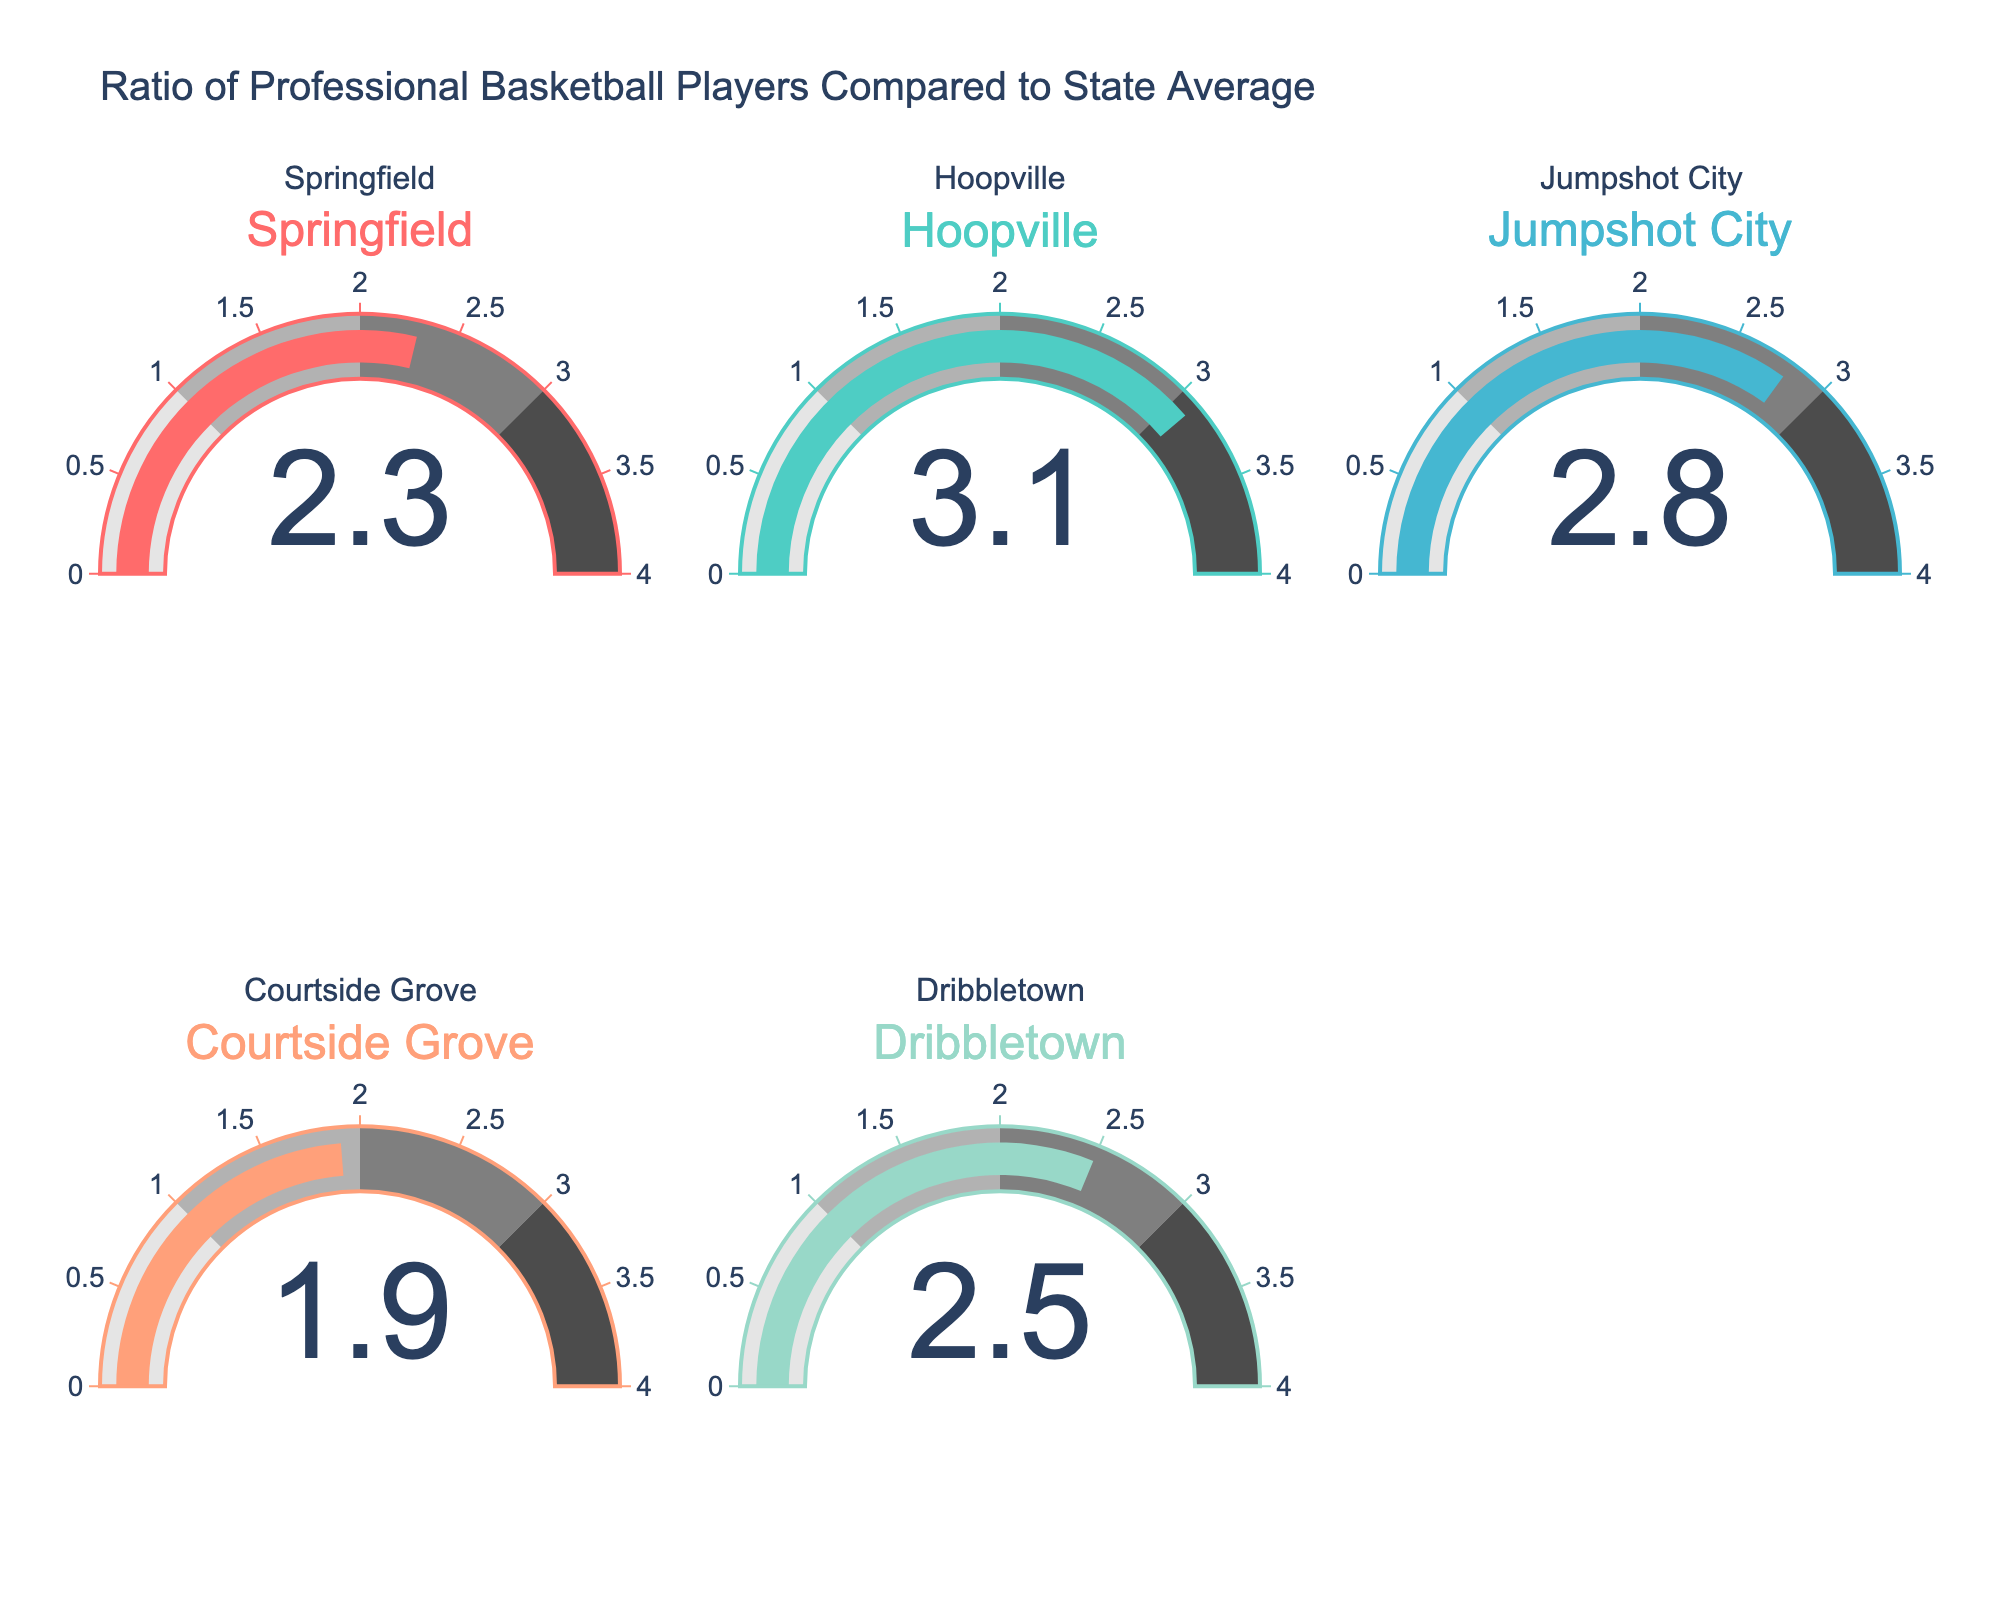Which town has the highest ratio of professional basketball players compared to the state average? By examining the gauges, the highest ratio gauge is in the second plot labeled "Hoopville" with a value of 3.1
Answer: Hoopville Which town has the lowest ratio of professional basketball players compared to the state average? The lowest ratio is found in the gauge labeled "Courtside Grove" with a value of 1.9
Answer: Courtside Grove What is the average ratio of professional basketball players for all towns? First, sum all the ratios: 2.3 (Springfield) + 3.1 (Hoopville) + 2.8 (Jumpshot City) + 1.9 (Courtside Grove) + 2.5 (Dribbletown) = 12.6. Then, divide by the number of towns: 12.6 / 5 = 2.52
Answer: 2.52 What is the total difference in ratios between the town with the highest and the town with the lowest ratio? The highest ratio is 3.1 (Hoopville), and the lowest is 1.9 (Courtside Grove). The difference is 3.1 - 1.9 = 1.2
Answer: 1.2 Which two towns have the closest ratios of professional basketball players compared to the state average? By inspecting the gauges, "Springfield" (2.3) and "Dribbletown" (2.5) are the closest with a difference of 2.5 - 2.3 = 0.2
Answer: Springfield and Dribbletown If the average ratio is 2.52, which towns are below this average? Identify the towns with ratios below 2.52: Springfield (2.3) and Courtside Grove (1.9) are both below the average
Answer: Springfield and Courtside Grove Which colored section of the gauge is mostly occupied by the ratio for "Jumpshot City"? "Jumpshot City" has a ratio of 2.8, which mostly occupies the third color range (2 to 3)
Answer: Third color range What is the ratio difference between "Springfield" and "Courtside Grove"? Springfield's ratio is 2.3, and Courtside Grove's ratio is 1.9. The difference is 2.3 - 1.9 = 0.4
Answer: 0.4 What is the combined ratio of "Jumpshot City" and "Dribbletown"? Jumpshot City has a ratio of 2.8, and Dribbletown has a ratio of 2.5. Combined ratio is 2.8 + 2.5 = 5.3
Answer: 5.3 